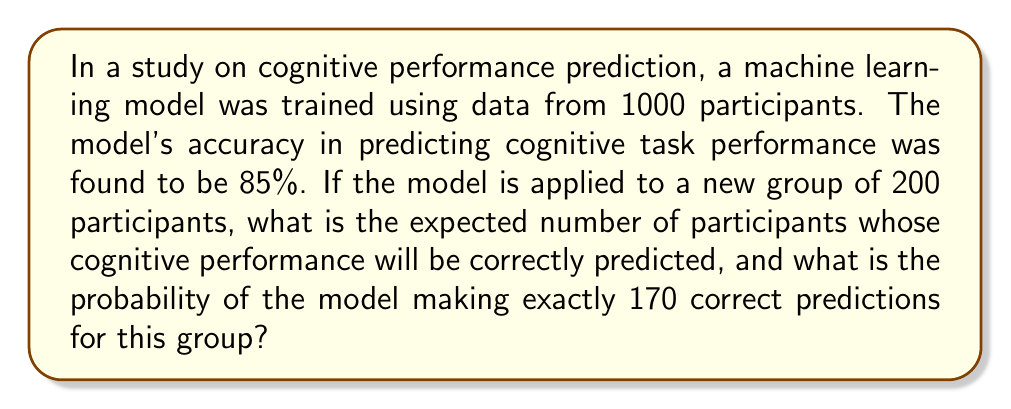Teach me how to tackle this problem. Let's approach this problem step-by-step:

1) Expected number of correct predictions:
   - The model's accuracy is 85% or 0.85
   - For 200 participants, the expected number of correct predictions is:
     $$ E = 200 \times 0.85 = 170 $$

2) Probability of exactly 170 correct predictions:
   - This scenario follows a binomial distribution
   - Let X be the number of correct predictions
   - We want to find P(X = 170)
   - The binomial probability formula is:
     $$ P(X = k) = \binom{n}{k} p^k (1-p)^{n-k} $$
     where n is the number of trials, k is the number of successes, and p is the probability of success

   - In our case: n = 200, k = 170, p = 0.85
   
   - Calculating the binomial coefficient:
     $$ \binom{200}{170} = \frac{200!}{170!(200-170)!} = \frac{200!}{170!30!} $$

   - Plugging into the formula:
     $$ P(X = 170) = \binom{200}{170} (0.85)^{170} (1-0.85)^{200-170} $$
     $$ = \binom{200}{170} (0.85)^{170} (0.15)^{30} $$

   - Using a calculator or computer for the final calculation:
     $$ P(X = 170) \approx 0.0548 $$

Therefore, the expected number of correct predictions is 170, and the probability of making exactly 170 correct predictions is approximately 0.0548 or 5.48%.
Answer: 170 expected correct predictions; 0.0548 probability of exactly 170 correct predictions 